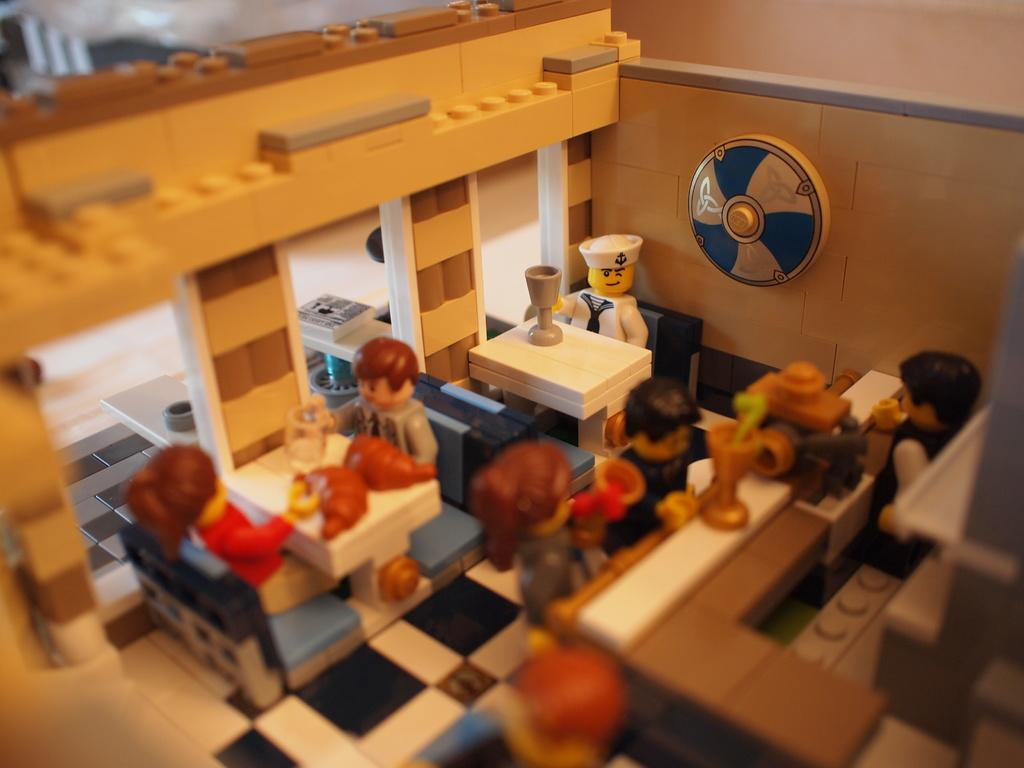What type of object is depicted in the image? The object is a toy house. Can you describe the toy house in more detail? Unfortunately, the provided facts do not offer any additional details about the toy house. How many eyes can be seen on the toy house in the image? There are no eyes present on the toy house in the image, as it is an inanimate object and does not have eyes. 